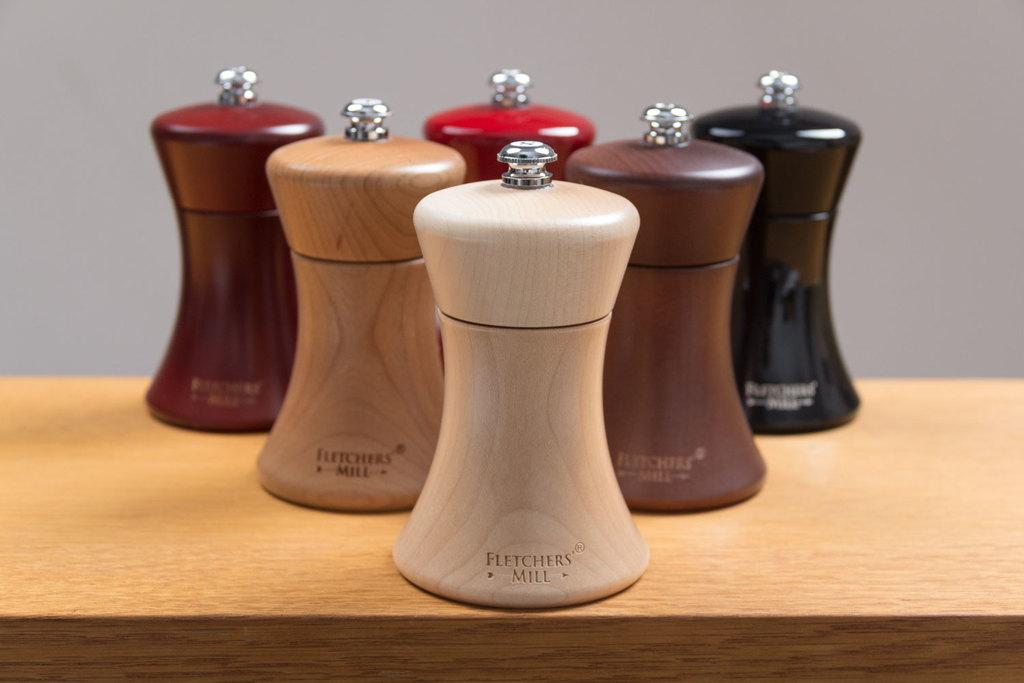What condiment containers are present in the image? There are salt and pepper bottles in the image. How would you describe the appearance of the salt and pepper bottles? The salt and pepper bottles are beautiful. On what surface are the salt and pepper bottles placed? The bottles are placed on a wooden table top. What color is the wall visible in the background of the image? There is a grey color wall in the background of the image. What rhythm is being played by the salt and pepper bottles in the image? There is no rhythm being played by the salt and pepper bottles in the image, as they are inanimate objects. 